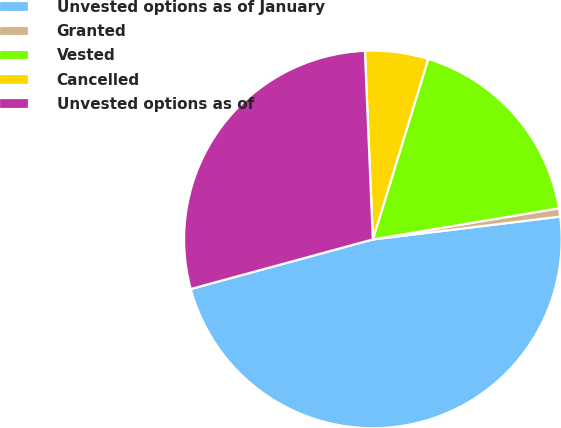<chart> <loc_0><loc_0><loc_500><loc_500><pie_chart><fcel>Unvested options as of January<fcel>Granted<fcel>Vested<fcel>Cancelled<fcel>Unvested options as of<nl><fcel>47.7%<fcel>0.71%<fcel>17.62%<fcel>5.41%<fcel>28.56%<nl></chart> 